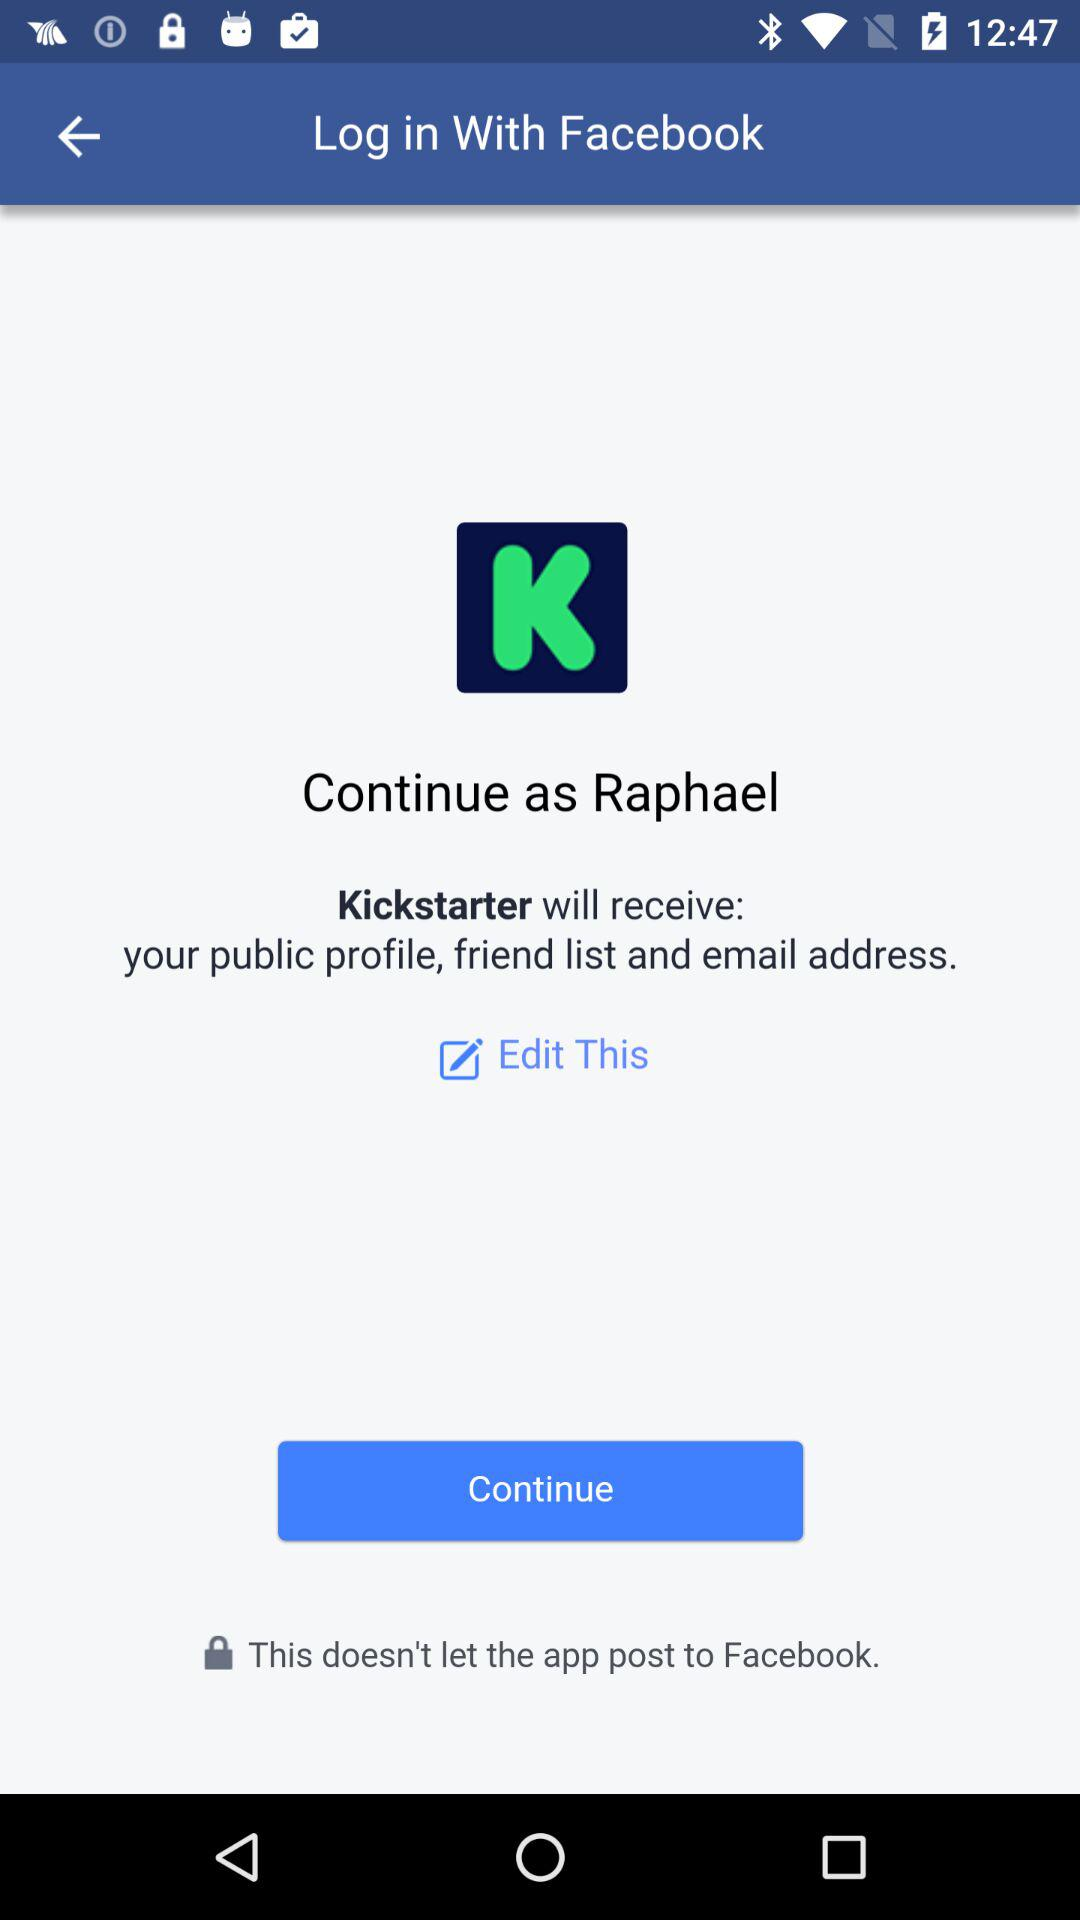What application has asked for permission? The application that has asked for permission is "Kickstarter". 